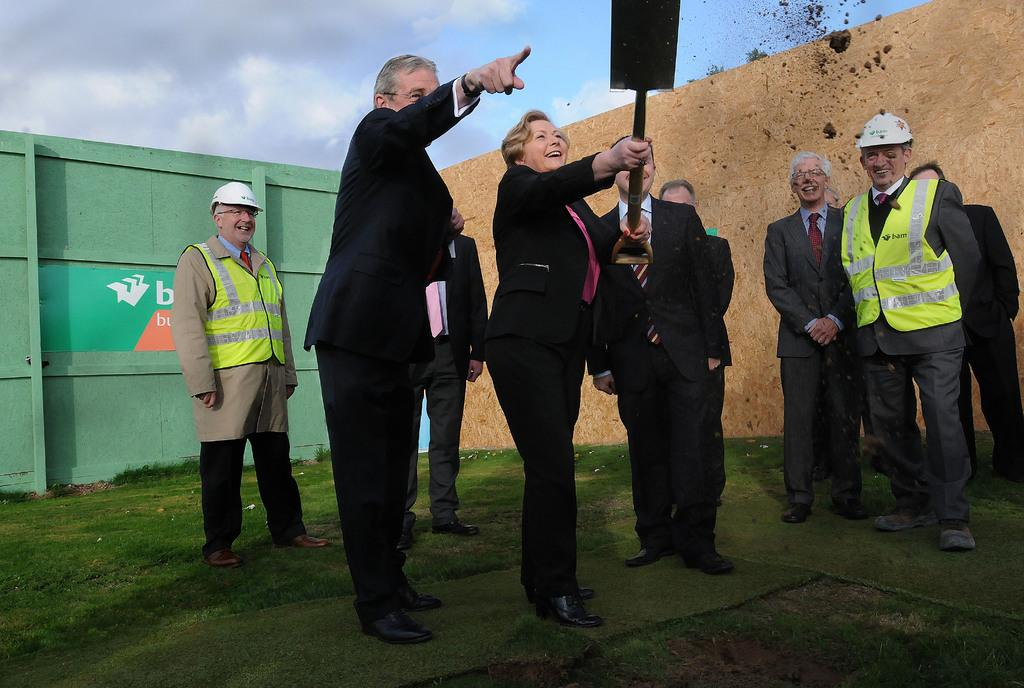How many people are in the image? There is a group of people in the image. What are the people doing in the image? The people are standing on the ground and smiling. What is one person holding in their hand? One person is holding an object in their hand. What can be seen in the background of the image? There is a wall in the background of the image. What is visible above the people in the image? The sky is visible above the people. What type of jam is being spread on the spoon in the image? There is no jam or spoon present in the image. 